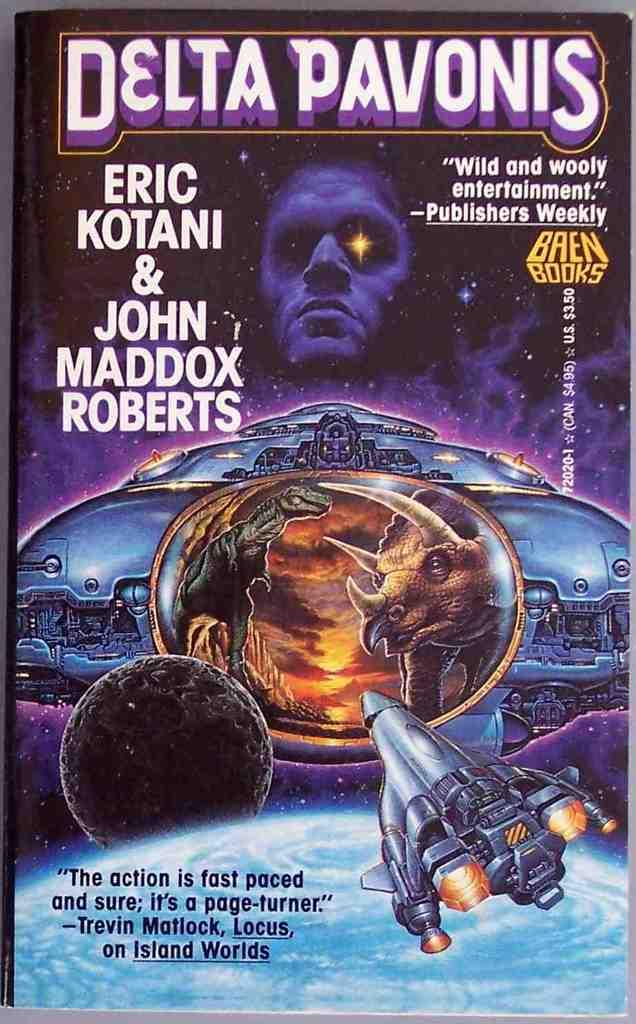What is depicted on the poster in the image? The poster contains a rocket, dinosaurs, and a person's face. What else can be seen on the poster besides the images? There are texts on the top of the poster. How many eyes can be seen on the dinosaurs in the image? There are no eyes visible on the dinosaurs in the image, as they are depicted in a stylized manner. 